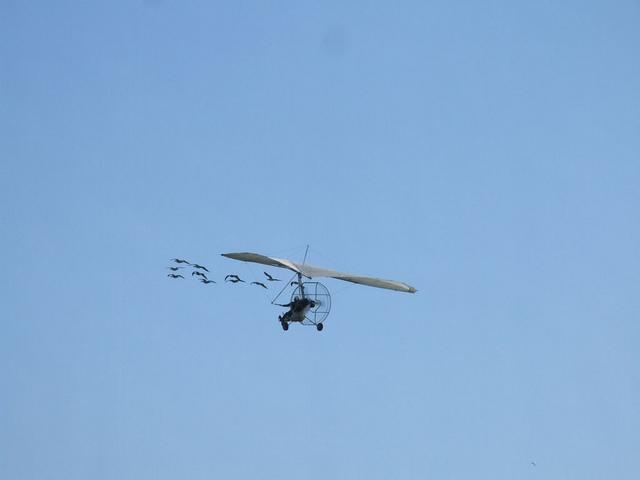Which object is/are in the greatest threat?
Select the accurate answer and provide explanation: 'Answer: answer
Rationale: rationale.'
Options: Pilot, birds, plane wings, plane wheels. Answer: birds.
Rationale: Birds fly all around a man in a glider in the air. birds have been known to cause accidents for planes. 